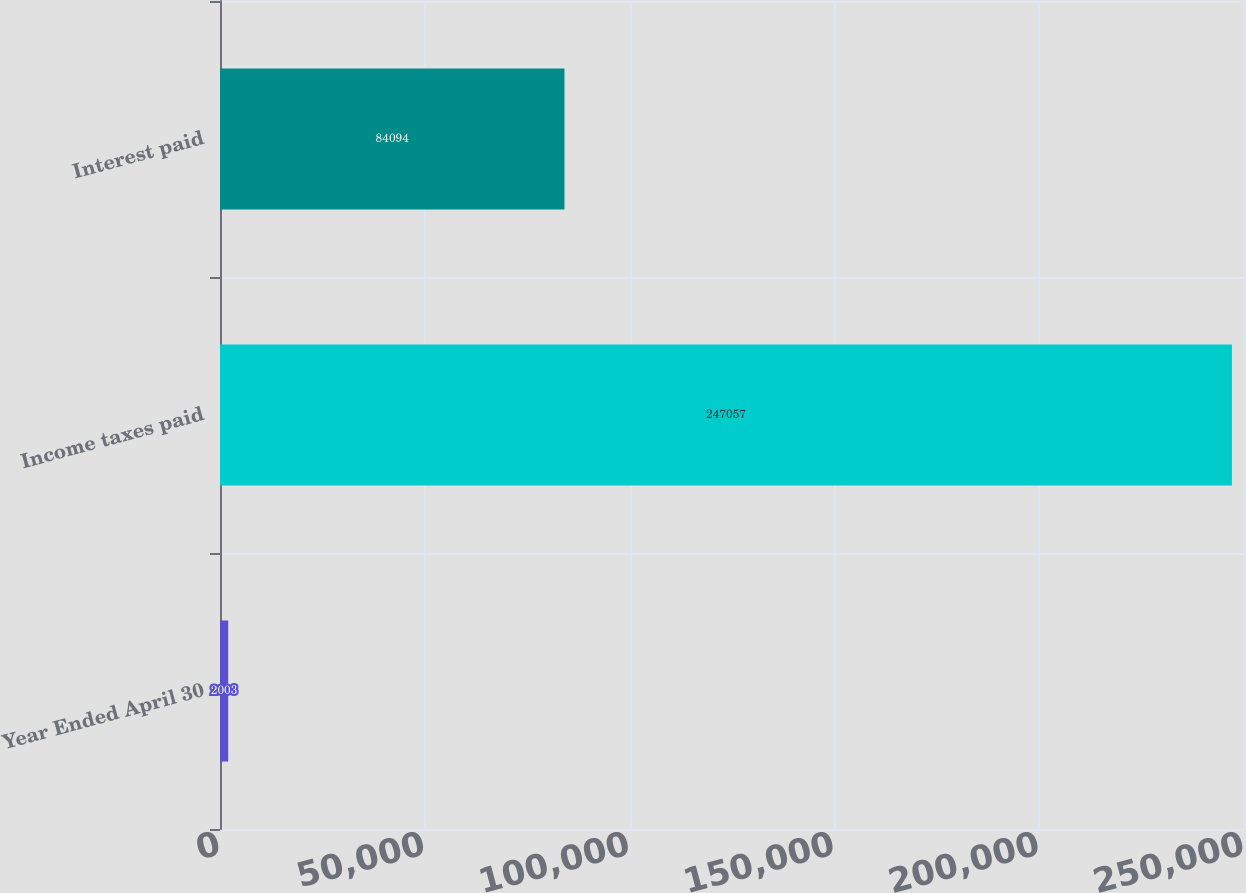Convert chart to OTSL. <chart><loc_0><loc_0><loc_500><loc_500><bar_chart><fcel>Year Ended April 30<fcel>Income taxes paid<fcel>Interest paid<nl><fcel>2003<fcel>247057<fcel>84094<nl></chart> 